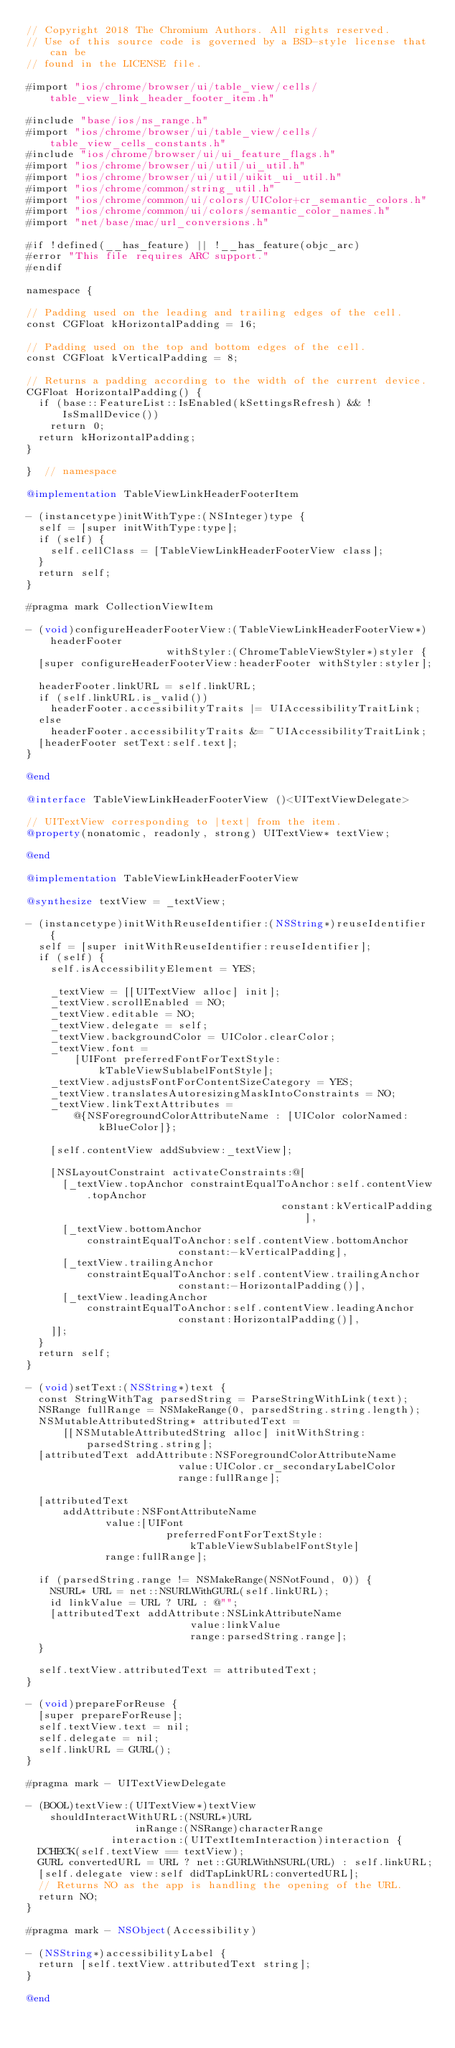<code> <loc_0><loc_0><loc_500><loc_500><_ObjectiveC_>// Copyright 2018 The Chromium Authors. All rights reserved.
// Use of this source code is governed by a BSD-style license that can be
// found in the LICENSE file.

#import "ios/chrome/browser/ui/table_view/cells/table_view_link_header_footer_item.h"

#include "base/ios/ns_range.h"
#import "ios/chrome/browser/ui/table_view/cells/table_view_cells_constants.h"
#include "ios/chrome/browser/ui/ui_feature_flags.h"
#import "ios/chrome/browser/ui/util/ui_util.h"
#import "ios/chrome/browser/ui/util/uikit_ui_util.h"
#import "ios/chrome/common/string_util.h"
#import "ios/chrome/common/ui/colors/UIColor+cr_semantic_colors.h"
#import "ios/chrome/common/ui/colors/semantic_color_names.h"
#import "net/base/mac/url_conversions.h"

#if !defined(__has_feature) || !__has_feature(objc_arc)
#error "This file requires ARC support."
#endif

namespace {

// Padding used on the leading and trailing edges of the cell.
const CGFloat kHorizontalPadding = 16;

// Padding used on the top and bottom edges of the cell.
const CGFloat kVerticalPadding = 8;

// Returns a padding according to the width of the current device.
CGFloat HorizontalPadding() {
  if (base::FeatureList::IsEnabled(kSettingsRefresh) && !IsSmallDevice())
    return 0;
  return kHorizontalPadding;
}

}  // namespace

@implementation TableViewLinkHeaderFooterItem

- (instancetype)initWithType:(NSInteger)type {
  self = [super initWithType:type];
  if (self) {
    self.cellClass = [TableViewLinkHeaderFooterView class];
  }
  return self;
}

#pragma mark CollectionViewItem

- (void)configureHeaderFooterView:(TableViewLinkHeaderFooterView*)headerFooter
                       withStyler:(ChromeTableViewStyler*)styler {
  [super configureHeaderFooterView:headerFooter withStyler:styler];

  headerFooter.linkURL = self.linkURL;
  if (self.linkURL.is_valid())
    headerFooter.accessibilityTraits |= UIAccessibilityTraitLink;
  else
    headerFooter.accessibilityTraits &= ~UIAccessibilityTraitLink;
  [headerFooter setText:self.text];
}

@end

@interface TableViewLinkHeaderFooterView ()<UITextViewDelegate>

// UITextView corresponding to |text| from the item.
@property(nonatomic, readonly, strong) UITextView* textView;

@end

@implementation TableViewLinkHeaderFooterView

@synthesize textView = _textView;

- (instancetype)initWithReuseIdentifier:(NSString*)reuseIdentifier {
  self = [super initWithReuseIdentifier:reuseIdentifier];
  if (self) {
    self.isAccessibilityElement = YES;

    _textView = [[UITextView alloc] init];
    _textView.scrollEnabled = NO;
    _textView.editable = NO;
    _textView.delegate = self;
    _textView.backgroundColor = UIColor.clearColor;
    _textView.font =
        [UIFont preferredFontForTextStyle:kTableViewSublabelFontStyle];
    _textView.adjustsFontForContentSizeCategory = YES;
    _textView.translatesAutoresizingMaskIntoConstraints = NO;
    _textView.linkTextAttributes =
        @{NSForegroundColorAttributeName : [UIColor colorNamed:kBlueColor]};

    [self.contentView addSubview:_textView];

    [NSLayoutConstraint activateConstraints:@[
      [_textView.topAnchor constraintEqualToAnchor:self.contentView.topAnchor
                                          constant:kVerticalPadding],
      [_textView.bottomAnchor
          constraintEqualToAnchor:self.contentView.bottomAnchor
                         constant:-kVerticalPadding],
      [_textView.trailingAnchor
          constraintEqualToAnchor:self.contentView.trailingAnchor
                         constant:-HorizontalPadding()],
      [_textView.leadingAnchor
          constraintEqualToAnchor:self.contentView.leadingAnchor
                         constant:HorizontalPadding()],
    ]];
  }
  return self;
}

- (void)setText:(NSString*)text {
  const StringWithTag parsedString = ParseStringWithLink(text);
  NSRange fullRange = NSMakeRange(0, parsedString.string.length);
  NSMutableAttributedString* attributedText =
      [[NSMutableAttributedString alloc] initWithString:parsedString.string];
  [attributedText addAttribute:NSForegroundColorAttributeName
                         value:UIColor.cr_secondaryLabelColor
                         range:fullRange];

  [attributedText
      addAttribute:NSFontAttributeName
             value:[UIFont
                       preferredFontForTextStyle:kTableViewSublabelFontStyle]
             range:fullRange];

  if (parsedString.range != NSMakeRange(NSNotFound, 0)) {
    NSURL* URL = net::NSURLWithGURL(self.linkURL);
    id linkValue = URL ? URL : @"";
    [attributedText addAttribute:NSLinkAttributeName
                           value:linkValue
                           range:parsedString.range];
  }

  self.textView.attributedText = attributedText;
}

- (void)prepareForReuse {
  [super prepareForReuse];
  self.textView.text = nil;
  self.delegate = nil;
  self.linkURL = GURL();
}

#pragma mark - UITextViewDelegate

- (BOOL)textView:(UITextView*)textView
    shouldInteractWithURL:(NSURL*)URL
                  inRange:(NSRange)characterRange
              interaction:(UITextItemInteraction)interaction {
  DCHECK(self.textView == textView);
  GURL convertedURL = URL ? net::GURLWithNSURL(URL) : self.linkURL;
  [self.delegate view:self didTapLinkURL:convertedURL];
  // Returns NO as the app is handling the opening of the URL.
  return NO;
}

#pragma mark - NSObject(Accessibility)

- (NSString*)accessibilityLabel {
  return [self.textView.attributedText string];
}

@end
</code> 